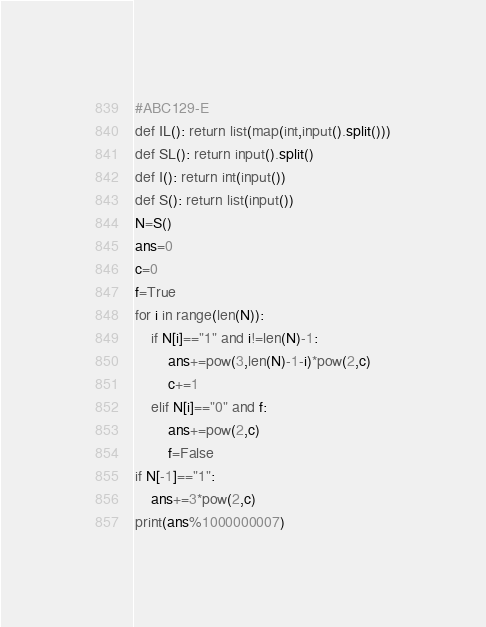<code> <loc_0><loc_0><loc_500><loc_500><_Python_>#ABC129-E
def IL(): return list(map(int,input().split()))
def SL(): return input().split()
def I(): return int(input())
def S(): return list(input())
N=S()
ans=0
c=0
f=True
for i in range(len(N)):
    if N[i]=="1" and i!=len(N)-1:
        ans+=pow(3,len(N)-1-i)*pow(2,c)
        c+=1
    elif N[i]=="0" and f:
        ans+=pow(2,c)
        f=False
if N[-1]=="1":
    ans+=3*pow(2,c)
print(ans%1000000007)</code> 